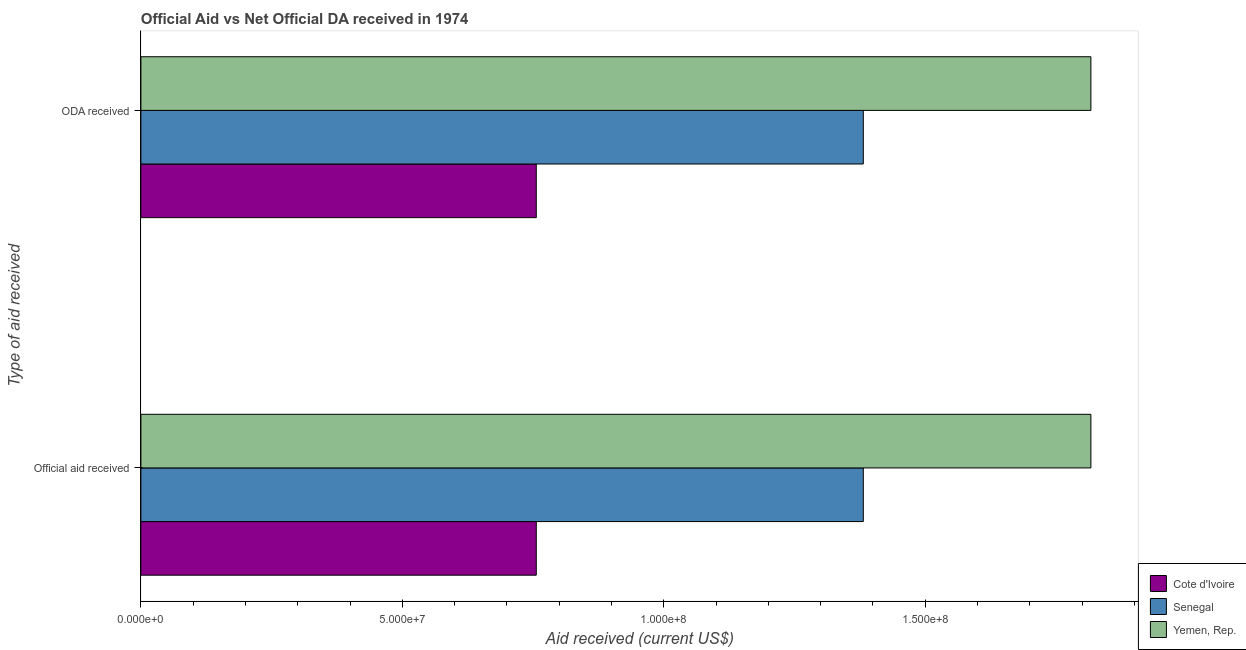How many groups of bars are there?
Give a very brief answer. 2. Are the number of bars per tick equal to the number of legend labels?
Give a very brief answer. Yes. Are the number of bars on each tick of the Y-axis equal?
Your answer should be compact. Yes. How many bars are there on the 2nd tick from the top?
Offer a terse response. 3. What is the label of the 2nd group of bars from the top?
Offer a very short reply. Official aid received. What is the official aid received in Senegal?
Provide a succinct answer. 1.38e+08. Across all countries, what is the maximum oda received?
Offer a very short reply. 1.82e+08. Across all countries, what is the minimum oda received?
Your answer should be very brief. 7.56e+07. In which country was the oda received maximum?
Offer a terse response. Yemen, Rep. In which country was the official aid received minimum?
Give a very brief answer. Cote d'Ivoire. What is the total oda received in the graph?
Give a very brief answer. 3.95e+08. What is the difference between the oda received in Senegal and that in Yemen, Rep.?
Ensure brevity in your answer.  -4.35e+07. What is the difference between the oda received in Cote d'Ivoire and the official aid received in Yemen, Rep.?
Keep it short and to the point. -1.06e+08. What is the average oda received per country?
Your answer should be very brief. 1.32e+08. What is the difference between the official aid received and oda received in Yemen, Rep.?
Your response must be concise. 0. In how many countries, is the oda received greater than 110000000 US$?
Make the answer very short. 2. What is the ratio of the oda received in Cote d'Ivoire to that in Yemen, Rep.?
Ensure brevity in your answer.  0.42. Is the official aid received in Senegal less than that in Yemen, Rep.?
Your response must be concise. Yes. What does the 2nd bar from the top in ODA received represents?
Ensure brevity in your answer.  Senegal. What does the 3rd bar from the bottom in ODA received represents?
Your answer should be very brief. Yemen, Rep. How many bars are there?
Keep it short and to the point. 6. Are all the bars in the graph horizontal?
Provide a short and direct response. Yes. How many countries are there in the graph?
Your response must be concise. 3. Where does the legend appear in the graph?
Ensure brevity in your answer.  Bottom right. How many legend labels are there?
Ensure brevity in your answer.  3. What is the title of the graph?
Give a very brief answer. Official Aid vs Net Official DA received in 1974 . Does "Mauritius" appear as one of the legend labels in the graph?
Give a very brief answer. No. What is the label or title of the X-axis?
Provide a succinct answer. Aid received (current US$). What is the label or title of the Y-axis?
Your answer should be compact. Type of aid received. What is the Aid received (current US$) of Cote d'Ivoire in Official aid received?
Your answer should be compact. 7.56e+07. What is the Aid received (current US$) of Senegal in Official aid received?
Provide a short and direct response. 1.38e+08. What is the Aid received (current US$) in Yemen, Rep. in Official aid received?
Keep it short and to the point. 1.82e+08. What is the Aid received (current US$) in Cote d'Ivoire in ODA received?
Ensure brevity in your answer.  7.56e+07. What is the Aid received (current US$) of Senegal in ODA received?
Ensure brevity in your answer.  1.38e+08. What is the Aid received (current US$) of Yemen, Rep. in ODA received?
Ensure brevity in your answer.  1.82e+08. Across all Type of aid received, what is the maximum Aid received (current US$) of Cote d'Ivoire?
Keep it short and to the point. 7.56e+07. Across all Type of aid received, what is the maximum Aid received (current US$) in Senegal?
Offer a terse response. 1.38e+08. Across all Type of aid received, what is the maximum Aid received (current US$) of Yemen, Rep.?
Your answer should be very brief. 1.82e+08. Across all Type of aid received, what is the minimum Aid received (current US$) in Cote d'Ivoire?
Provide a short and direct response. 7.56e+07. Across all Type of aid received, what is the minimum Aid received (current US$) in Senegal?
Your response must be concise. 1.38e+08. Across all Type of aid received, what is the minimum Aid received (current US$) in Yemen, Rep.?
Keep it short and to the point. 1.82e+08. What is the total Aid received (current US$) in Cote d'Ivoire in the graph?
Provide a succinct answer. 1.51e+08. What is the total Aid received (current US$) in Senegal in the graph?
Make the answer very short. 2.76e+08. What is the total Aid received (current US$) of Yemen, Rep. in the graph?
Provide a short and direct response. 3.63e+08. What is the difference between the Aid received (current US$) of Cote d'Ivoire in Official aid received and that in ODA received?
Offer a very short reply. 0. What is the difference between the Aid received (current US$) in Senegal in Official aid received and that in ODA received?
Ensure brevity in your answer.  0. What is the difference between the Aid received (current US$) of Yemen, Rep. in Official aid received and that in ODA received?
Offer a very short reply. 0. What is the difference between the Aid received (current US$) of Cote d'Ivoire in Official aid received and the Aid received (current US$) of Senegal in ODA received?
Your response must be concise. -6.25e+07. What is the difference between the Aid received (current US$) of Cote d'Ivoire in Official aid received and the Aid received (current US$) of Yemen, Rep. in ODA received?
Ensure brevity in your answer.  -1.06e+08. What is the difference between the Aid received (current US$) in Senegal in Official aid received and the Aid received (current US$) in Yemen, Rep. in ODA received?
Make the answer very short. -4.35e+07. What is the average Aid received (current US$) of Cote d'Ivoire per Type of aid received?
Give a very brief answer. 7.56e+07. What is the average Aid received (current US$) in Senegal per Type of aid received?
Ensure brevity in your answer.  1.38e+08. What is the average Aid received (current US$) of Yemen, Rep. per Type of aid received?
Make the answer very short. 1.82e+08. What is the difference between the Aid received (current US$) in Cote d'Ivoire and Aid received (current US$) in Senegal in Official aid received?
Offer a terse response. -6.25e+07. What is the difference between the Aid received (current US$) in Cote d'Ivoire and Aid received (current US$) in Yemen, Rep. in Official aid received?
Your answer should be compact. -1.06e+08. What is the difference between the Aid received (current US$) of Senegal and Aid received (current US$) of Yemen, Rep. in Official aid received?
Offer a terse response. -4.35e+07. What is the difference between the Aid received (current US$) in Cote d'Ivoire and Aid received (current US$) in Senegal in ODA received?
Offer a very short reply. -6.25e+07. What is the difference between the Aid received (current US$) of Cote d'Ivoire and Aid received (current US$) of Yemen, Rep. in ODA received?
Ensure brevity in your answer.  -1.06e+08. What is the difference between the Aid received (current US$) in Senegal and Aid received (current US$) in Yemen, Rep. in ODA received?
Provide a succinct answer. -4.35e+07. What is the ratio of the Aid received (current US$) of Cote d'Ivoire in Official aid received to that in ODA received?
Ensure brevity in your answer.  1. What is the ratio of the Aid received (current US$) in Senegal in Official aid received to that in ODA received?
Give a very brief answer. 1. What is the difference between the highest and the second highest Aid received (current US$) in Cote d'Ivoire?
Ensure brevity in your answer.  0. What is the difference between the highest and the second highest Aid received (current US$) of Yemen, Rep.?
Make the answer very short. 0. What is the difference between the highest and the lowest Aid received (current US$) in Cote d'Ivoire?
Your answer should be compact. 0. What is the difference between the highest and the lowest Aid received (current US$) in Senegal?
Ensure brevity in your answer.  0. What is the difference between the highest and the lowest Aid received (current US$) of Yemen, Rep.?
Provide a short and direct response. 0. 